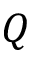<formula> <loc_0><loc_0><loc_500><loc_500>Q</formula> 